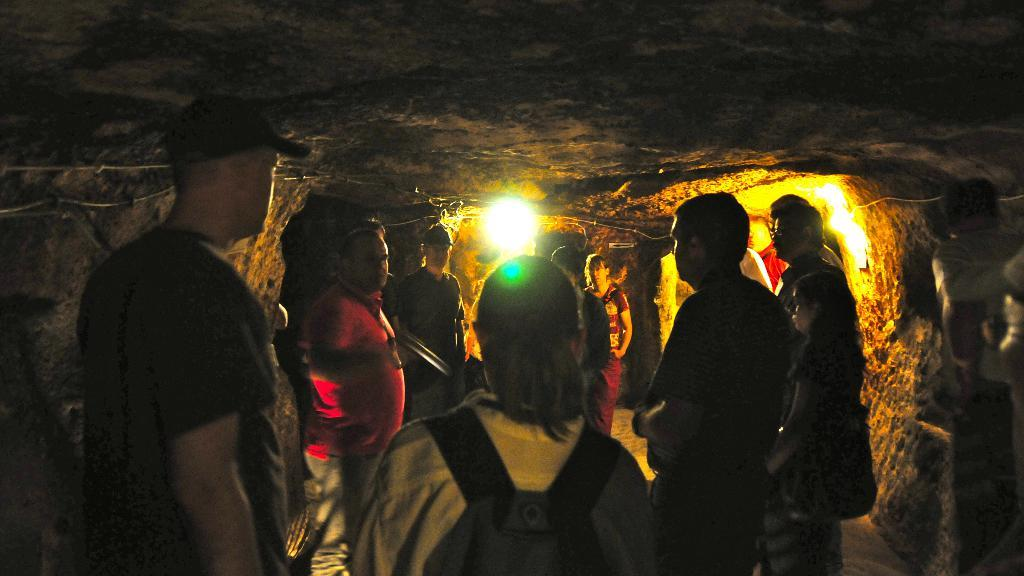Where might the image have been taken? The image might be taken inside a cave. Can you describe the people in the image? There is a group of people in the image. What can be seen at the top of the image? There are rocks at the top of the image. What is the source of light in the image? There is light visible in the background of the image. What type of chicken is being carried by the dolls in the image? There are no dolls or chickens present in the image. What type of voyage are the people in the image embarking on? The image does not provide any information about a voyage or the people's intentions. 